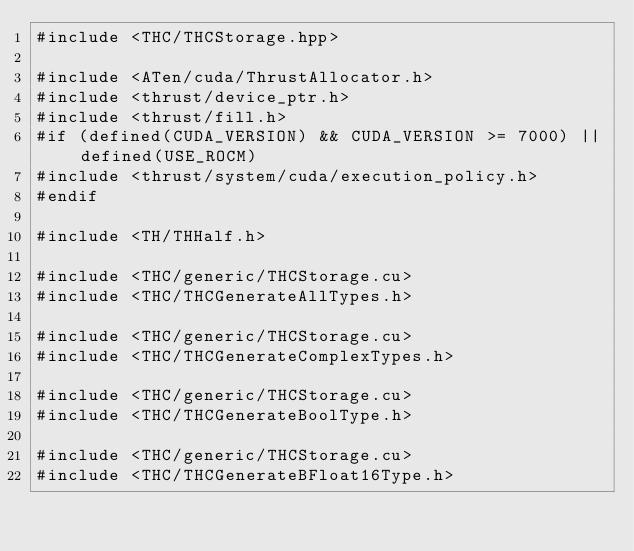<code> <loc_0><loc_0><loc_500><loc_500><_Cuda_>#include <THC/THCStorage.hpp>

#include <ATen/cuda/ThrustAllocator.h>
#include <thrust/device_ptr.h>
#include <thrust/fill.h>
#if (defined(CUDA_VERSION) && CUDA_VERSION >= 7000) || defined(USE_ROCM)
#include <thrust/system/cuda/execution_policy.h>
#endif

#include <TH/THHalf.h>

#include <THC/generic/THCStorage.cu>
#include <THC/THCGenerateAllTypes.h>

#include <THC/generic/THCStorage.cu>
#include <THC/THCGenerateComplexTypes.h>

#include <THC/generic/THCStorage.cu>
#include <THC/THCGenerateBoolType.h>

#include <THC/generic/THCStorage.cu>
#include <THC/THCGenerateBFloat16Type.h>
</code> 